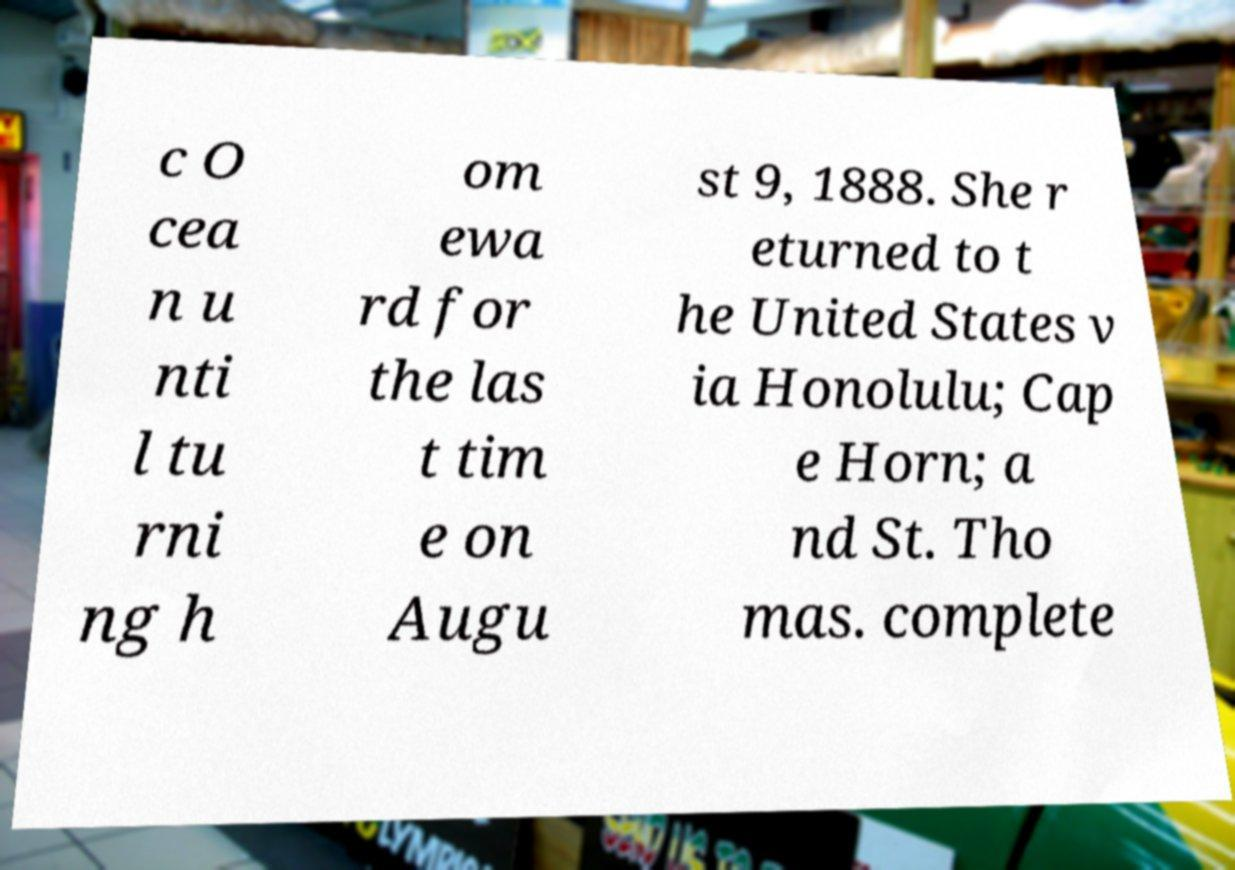I need the written content from this picture converted into text. Can you do that? c O cea n u nti l tu rni ng h om ewa rd for the las t tim e on Augu st 9, 1888. She r eturned to t he United States v ia Honolulu; Cap e Horn; a nd St. Tho mas. complete 